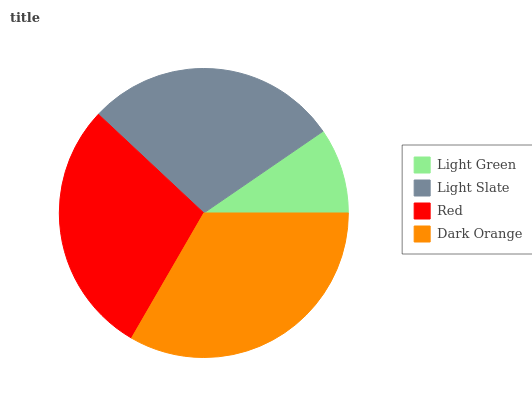Is Light Green the minimum?
Answer yes or no. Yes. Is Dark Orange the maximum?
Answer yes or no. Yes. Is Light Slate the minimum?
Answer yes or no. No. Is Light Slate the maximum?
Answer yes or no. No. Is Light Slate greater than Light Green?
Answer yes or no. Yes. Is Light Green less than Light Slate?
Answer yes or no. Yes. Is Light Green greater than Light Slate?
Answer yes or no. No. Is Light Slate less than Light Green?
Answer yes or no. No. Is Red the high median?
Answer yes or no. Yes. Is Light Slate the low median?
Answer yes or no. Yes. Is Dark Orange the high median?
Answer yes or no. No. Is Dark Orange the low median?
Answer yes or no. No. 